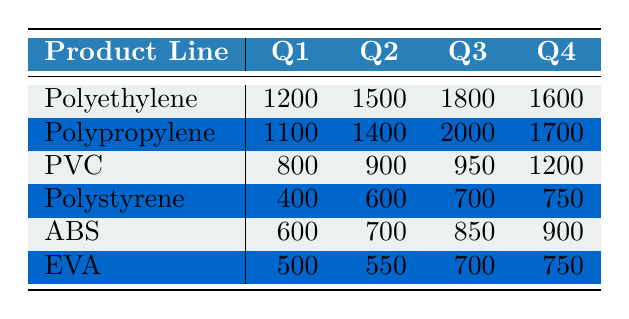What is the customer demand for Polyethylene in Q2? The table indicates that the value for Polyethylene in Q2 is 1500.
Answer: 1500 Which product line has the highest demand in Q3? By comparing the values in Q3, Polypropylene has the highest demand at 2000.
Answer: Polypropylene What is the total demand for PVC across all quarters? The total demand for PVC is calculated by summing the values: 800 + 900 + 950 + 1200 = 3850.
Answer: 3850 Is the demand for Polystyrene in Q4 greater than the demand for ABS in Q3? Looking at the table, Polystyrene in Q4 has a demand of 750, while ABS in Q3 has a demand of 850. Since 750 is less than 850, the statement is false.
Answer: No What is the difference between the highest and lowest demands in Q1? The highest demand in Q1 is for Polyethylene at 1200, and the lowest is for Polystyrene at 400. The difference is 1200 - 400 = 800.
Answer: 800 What is the average demand for EVA across all quarters? The average for EVA is calculated by summing its quarterly values: 500 + 550 + 700 + 750 = 2500. The average is 2500 divided by 4, which equals 625.
Answer: 625 Which product line has a consistent demand increase from Q1 to Q3? By reviewing the demands, both Polyethylene and Polypropylene show a consistent increase from Q1 (1200 and 1100 respectively) to Q3 (1800 and 2000 respectively).
Answer: Polyethylene and Polypropylene Is the total demand across all quarters for PVC higher than that for Polystyrene? The total demand for PVC is 3850, while for Polystyrene it is 2750 (400 + 600 + 700 + 750). Since 3850 is greater than 2750, the answer is yes.
Answer: Yes What is the customer demand for Polypropylene in Q4 compared to Q1? In Q4, Polypropylene has a demand of 1700, which is greater than its demand in Q1, which is 1100. The difference is therefore 1700 - 1100 = 600.
Answer: 600 